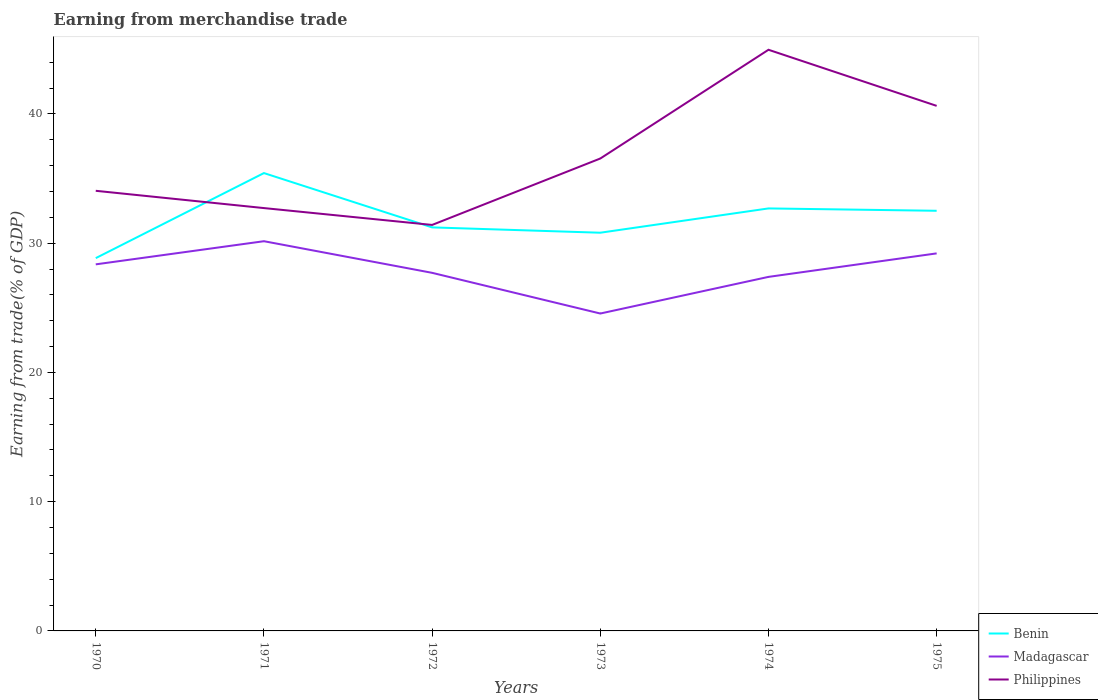Across all years, what is the maximum earnings from trade in Madagascar?
Your answer should be compact. 24.56. In which year was the earnings from trade in Philippines maximum?
Keep it short and to the point. 1972. What is the total earnings from trade in Philippines in the graph?
Keep it short and to the point. 2.64. What is the difference between the highest and the second highest earnings from trade in Madagascar?
Your answer should be compact. 5.59. What is the difference between the highest and the lowest earnings from trade in Benin?
Your answer should be very brief. 3. Is the earnings from trade in Philippines strictly greater than the earnings from trade in Madagascar over the years?
Your answer should be compact. No. What is the difference between two consecutive major ticks on the Y-axis?
Provide a short and direct response. 10. Does the graph contain grids?
Offer a terse response. No. Where does the legend appear in the graph?
Ensure brevity in your answer.  Bottom right. What is the title of the graph?
Keep it short and to the point. Earning from merchandise trade. What is the label or title of the Y-axis?
Make the answer very short. Earning from trade(% of GDP). What is the Earning from trade(% of GDP) of Benin in 1970?
Keep it short and to the point. 28.84. What is the Earning from trade(% of GDP) in Madagascar in 1970?
Your response must be concise. 28.36. What is the Earning from trade(% of GDP) in Philippines in 1970?
Your response must be concise. 34.05. What is the Earning from trade(% of GDP) in Benin in 1971?
Give a very brief answer. 35.42. What is the Earning from trade(% of GDP) of Madagascar in 1971?
Offer a very short reply. 30.15. What is the Earning from trade(% of GDP) in Philippines in 1971?
Keep it short and to the point. 32.71. What is the Earning from trade(% of GDP) of Benin in 1972?
Your answer should be compact. 31.22. What is the Earning from trade(% of GDP) in Madagascar in 1972?
Provide a short and direct response. 27.7. What is the Earning from trade(% of GDP) in Philippines in 1972?
Your answer should be compact. 31.41. What is the Earning from trade(% of GDP) of Benin in 1973?
Offer a very short reply. 30.81. What is the Earning from trade(% of GDP) in Madagascar in 1973?
Give a very brief answer. 24.56. What is the Earning from trade(% of GDP) in Philippines in 1973?
Your answer should be compact. 36.55. What is the Earning from trade(% of GDP) in Benin in 1974?
Make the answer very short. 32.69. What is the Earning from trade(% of GDP) in Madagascar in 1974?
Your answer should be very brief. 27.39. What is the Earning from trade(% of GDP) in Philippines in 1974?
Keep it short and to the point. 44.96. What is the Earning from trade(% of GDP) of Benin in 1975?
Your answer should be very brief. 32.5. What is the Earning from trade(% of GDP) of Madagascar in 1975?
Your answer should be compact. 29.21. What is the Earning from trade(% of GDP) in Philippines in 1975?
Offer a very short reply. 40.62. Across all years, what is the maximum Earning from trade(% of GDP) of Benin?
Give a very brief answer. 35.42. Across all years, what is the maximum Earning from trade(% of GDP) of Madagascar?
Offer a terse response. 30.15. Across all years, what is the maximum Earning from trade(% of GDP) of Philippines?
Ensure brevity in your answer.  44.96. Across all years, what is the minimum Earning from trade(% of GDP) in Benin?
Provide a succinct answer. 28.84. Across all years, what is the minimum Earning from trade(% of GDP) of Madagascar?
Offer a terse response. 24.56. Across all years, what is the minimum Earning from trade(% of GDP) of Philippines?
Your answer should be compact. 31.41. What is the total Earning from trade(% of GDP) of Benin in the graph?
Provide a short and direct response. 191.48. What is the total Earning from trade(% of GDP) in Madagascar in the graph?
Offer a terse response. 167.37. What is the total Earning from trade(% of GDP) in Philippines in the graph?
Provide a succinct answer. 220.31. What is the difference between the Earning from trade(% of GDP) in Benin in 1970 and that in 1971?
Keep it short and to the point. -6.58. What is the difference between the Earning from trade(% of GDP) in Madagascar in 1970 and that in 1971?
Provide a short and direct response. -1.79. What is the difference between the Earning from trade(% of GDP) in Philippines in 1970 and that in 1971?
Your answer should be compact. 1.34. What is the difference between the Earning from trade(% of GDP) in Benin in 1970 and that in 1972?
Offer a very short reply. -2.38. What is the difference between the Earning from trade(% of GDP) of Madagascar in 1970 and that in 1972?
Give a very brief answer. 0.66. What is the difference between the Earning from trade(% of GDP) in Philippines in 1970 and that in 1972?
Your response must be concise. 2.64. What is the difference between the Earning from trade(% of GDP) in Benin in 1970 and that in 1973?
Your answer should be very brief. -1.97. What is the difference between the Earning from trade(% of GDP) in Madagascar in 1970 and that in 1973?
Ensure brevity in your answer.  3.8. What is the difference between the Earning from trade(% of GDP) of Philippines in 1970 and that in 1973?
Provide a short and direct response. -2.5. What is the difference between the Earning from trade(% of GDP) of Benin in 1970 and that in 1974?
Provide a short and direct response. -3.85. What is the difference between the Earning from trade(% of GDP) in Madagascar in 1970 and that in 1974?
Offer a very short reply. 0.97. What is the difference between the Earning from trade(% of GDP) of Philippines in 1970 and that in 1974?
Your response must be concise. -10.91. What is the difference between the Earning from trade(% of GDP) in Benin in 1970 and that in 1975?
Offer a very short reply. -3.66. What is the difference between the Earning from trade(% of GDP) of Madagascar in 1970 and that in 1975?
Provide a succinct answer. -0.85. What is the difference between the Earning from trade(% of GDP) of Philippines in 1970 and that in 1975?
Offer a very short reply. -6.57. What is the difference between the Earning from trade(% of GDP) of Benin in 1971 and that in 1972?
Give a very brief answer. 4.2. What is the difference between the Earning from trade(% of GDP) in Madagascar in 1971 and that in 1972?
Keep it short and to the point. 2.45. What is the difference between the Earning from trade(% of GDP) in Philippines in 1971 and that in 1972?
Give a very brief answer. 1.3. What is the difference between the Earning from trade(% of GDP) of Benin in 1971 and that in 1973?
Provide a succinct answer. 4.61. What is the difference between the Earning from trade(% of GDP) in Madagascar in 1971 and that in 1973?
Make the answer very short. 5.59. What is the difference between the Earning from trade(% of GDP) of Philippines in 1971 and that in 1973?
Keep it short and to the point. -3.83. What is the difference between the Earning from trade(% of GDP) of Benin in 1971 and that in 1974?
Provide a short and direct response. 2.74. What is the difference between the Earning from trade(% of GDP) in Madagascar in 1971 and that in 1974?
Make the answer very short. 2.76. What is the difference between the Earning from trade(% of GDP) of Philippines in 1971 and that in 1974?
Provide a short and direct response. -12.25. What is the difference between the Earning from trade(% of GDP) in Benin in 1971 and that in 1975?
Ensure brevity in your answer.  2.92. What is the difference between the Earning from trade(% of GDP) of Madagascar in 1971 and that in 1975?
Your response must be concise. 0.94. What is the difference between the Earning from trade(% of GDP) of Philippines in 1971 and that in 1975?
Give a very brief answer. -7.91. What is the difference between the Earning from trade(% of GDP) in Benin in 1972 and that in 1973?
Your answer should be very brief. 0.41. What is the difference between the Earning from trade(% of GDP) in Madagascar in 1972 and that in 1973?
Your answer should be very brief. 3.15. What is the difference between the Earning from trade(% of GDP) in Philippines in 1972 and that in 1973?
Keep it short and to the point. -5.14. What is the difference between the Earning from trade(% of GDP) in Benin in 1972 and that in 1974?
Ensure brevity in your answer.  -1.47. What is the difference between the Earning from trade(% of GDP) in Madagascar in 1972 and that in 1974?
Your response must be concise. 0.31. What is the difference between the Earning from trade(% of GDP) of Philippines in 1972 and that in 1974?
Provide a short and direct response. -13.55. What is the difference between the Earning from trade(% of GDP) of Benin in 1972 and that in 1975?
Make the answer very short. -1.28. What is the difference between the Earning from trade(% of GDP) of Madagascar in 1972 and that in 1975?
Your answer should be very brief. -1.51. What is the difference between the Earning from trade(% of GDP) in Philippines in 1972 and that in 1975?
Ensure brevity in your answer.  -9.21. What is the difference between the Earning from trade(% of GDP) of Benin in 1973 and that in 1974?
Give a very brief answer. -1.88. What is the difference between the Earning from trade(% of GDP) of Madagascar in 1973 and that in 1974?
Offer a very short reply. -2.84. What is the difference between the Earning from trade(% of GDP) in Philippines in 1973 and that in 1974?
Offer a terse response. -8.41. What is the difference between the Earning from trade(% of GDP) in Benin in 1973 and that in 1975?
Provide a succinct answer. -1.7. What is the difference between the Earning from trade(% of GDP) of Madagascar in 1973 and that in 1975?
Your answer should be compact. -4.65. What is the difference between the Earning from trade(% of GDP) of Philippines in 1973 and that in 1975?
Offer a very short reply. -4.07. What is the difference between the Earning from trade(% of GDP) of Benin in 1974 and that in 1975?
Your response must be concise. 0.18. What is the difference between the Earning from trade(% of GDP) of Madagascar in 1974 and that in 1975?
Your response must be concise. -1.82. What is the difference between the Earning from trade(% of GDP) of Philippines in 1974 and that in 1975?
Provide a succinct answer. 4.34. What is the difference between the Earning from trade(% of GDP) in Benin in 1970 and the Earning from trade(% of GDP) in Madagascar in 1971?
Provide a short and direct response. -1.31. What is the difference between the Earning from trade(% of GDP) in Benin in 1970 and the Earning from trade(% of GDP) in Philippines in 1971?
Offer a very short reply. -3.87. What is the difference between the Earning from trade(% of GDP) of Madagascar in 1970 and the Earning from trade(% of GDP) of Philippines in 1971?
Give a very brief answer. -4.35. What is the difference between the Earning from trade(% of GDP) in Benin in 1970 and the Earning from trade(% of GDP) in Madagascar in 1972?
Your response must be concise. 1.14. What is the difference between the Earning from trade(% of GDP) in Benin in 1970 and the Earning from trade(% of GDP) in Philippines in 1972?
Your answer should be compact. -2.57. What is the difference between the Earning from trade(% of GDP) in Madagascar in 1970 and the Earning from trade(% of GDP) in Philippines in 1972?
Make the answer very short. -3.05. What is the difference between the Earning from trade(% of GDP) of Benin in 1970 and the Earning from trade(% of GDP) of Madagascar in 1973?
Offer a terse response. 4.29. What is the difference between the Earning from trade(% of GDP) of Benin in 1970 and the Earning from trade(% of GDP) of Philippines in 1973?
Ensure brevity in your answer.  -7.71. What is the difference between the Earning from trade(% of GDP) in Madagascar in 1970 and the Earning from trade(% of GDP) in Philippines in 1973?
Make the answer very short. -8.19. What is the difference between the Earning from trade(% of GDP) in Benin in 1970 and the Earning from trade(% of GDP) in Madagascar in 1974?
Provide a short and direct response. 1.45. What is the difference between the Earning from trade(% of GDP) in Benin in 1970 and the Earning from trade(% of GDP) in Philippines in 1974?
Offer a terse response. -16.12. What is the difference between the Earning from trade(% of GDP) of Madagascar in 1970 and the Earning from trade(% of GDP) of Philippines in 1974?
Keep it short and to the point. -16.6. What is the difference between the Earning from trade(% of GDP) of Benin in 1970 and the Earning from trade(% of GDP) of Madagascar in 1975?
Your response must be concise. -0.37. What is the difference between the Earning from trade(% of GDP) of Benin in 1970 and the Earning from trade(% of GDP) of Philippines in 1975?
Provide a short and direct response. -11.78. What is the difference between the Earning from trade(% of GDP) of Madagascar in 1970 and the Earning from trade(% of GDP) of Philippines in 1975?
Your answer should be very brief. -12.26. What is the difference between the Earning from trade(% of GDP) of Benin in 1971 and the Earning from trade(% of GDP) of Madagascar in 1972?
Provide a short and direct response. 7.72. What is the difference between the Earning from trade(% of GDP) in Benin in 1971 and the Earning from trade(% of GDP) in Philippines in 1972?
Make the answer very short. 4.01. What is the difference between the Earning from trade(% of GDP) in Madagascar in 1971 and the Earning from trade(% of GDP) in Philippines in 1972?
Ensure brevity in your answer.  -1.26. What is the difference between the Earning from trade(% of GDP) in Benin in 1971 and the Earning from trade(% of GDP) in Madagascar in 1973?
Your response must be concise. 10.87. What is the difference between the Earning from trade(% of GDP) of Benin in 1971 and the Earning from trade(% of GDP) of Philippines in 1973?
Your answer should be very brief. -1.13. What is the difference between the Earning from trade(% of GDP) in Madagascar in 1971 and the Earning from trade(% of GDP) in Philippines in 1973?
Provide a short and direct response. -6.4. What is the difference between the Earning from trade(% of GDP) of Benin in 1971 and the Earning from trade(% of GDP) of Madagascar in 1974?
Give a very brief answer. 8.03. What is the difference between the Earning from trade(% of GDP) of Benin in 1971 and the Earning from trade(% of GDP) of Philippines in 1974?
Provide a short and direct response. -9.54. What is the difference between the Earning from trade(% of GDP) of Madagascar in 1971 and the Earning from trade(% of GDP) of Philippines in 1974?
Your answer should be very brief. -14.81. What is the difference between the Earning from trade(% of GDP) in Benin in 1971 and the Earning from trade(% of GDP) in Madagascar in 1975?
Offer a very short reply. 6.21. What is the difference between the Earning from trade(% of GDP) of Benin in 1971 and the Earning from trade(% of GDP) of Philippines in 1975?
Provide a short and direct response. -5.2. What is the difference between the Earning from trade(% of GDP) in Madagascar in 1971 and the Earning from trade(% of GDP) in Philippines in 1975?
Ensure brevity in your answer.  -10.47. What is the difference between the Earning from trade(% of GDP) in Benin in 1972 and the Earning from trade(% of GDP) in Madagascar in 1973?
Keep it short and to the point. 6.66. What is the difference between the Earning from trade(% of GDP) in Benin in 1972 and the Earning from trade(% of GDP) in Philippines in 1973?
Your answer should be very brief. -5.33. What is the difference between the Earning from trade(% of GDP) in Madagascar in 1972 and the Earning from trade(% of GDP) in Philippines in 1973?
Your answer should be compact. -8.84. What is the difference between the Earning from trade(% of GDP) in Benin in 1972 and the Earning from trade(% of GDP) in Madagascar in 1974?
Your answer should be compact. 3.83. What is the difference between the Earning from trade(% of GDP) in Benin in 1972 and the Earning from trade(% of GDP) in Philippines in 1974?
Give a very brief answer. -13.74. What is the difference between the Earning from trade(% of GDP) of Madagascar in 1972 and the Earning from trade(% of GDP) of Philippines in 1974?
Provide a succinct answer. -17.26. What is the difference between the Earning from trade(% of GDP) of Benin in 1972 and the Earning from trade(% of GDP) of Madagascar in 1975?
Give a very brief answer. 2.01. What is the difference between the Earning from trade(% of GDP) in Benin in 1972 and the Earning from trade(% of GDP) in Philippines in 1975?
Provide a succinct answer. -9.4. What is the difference between the Earning from trade(% of GDP) of Madagascar in 1972 and the Earning from trade(% of GDP) of Philippines in 1975?
Your response must be concise. -12.92. What is the difference between the Earning from trade(% of GDP) of Benin in 1973 and the Earning from trade(% of GDP) of Madagascar in 1974?
Keep it short and to the point. 3.42. What is the difference between the Earning from trade(% of GDP) in Benin in 1973 and the Earning from trade(% of GDP) in Philippines in 1974?
Your response must be concise. -14.15. What is the difference between the Earning from trade(% of GDP) in Madagascar in 1973 and the Earning from trade(% of GDP) in Philippines in 1974?
Give a very brief answer. -20.41. What is the difference between the Earning from trade(% of GDP) in Benin in 1973 and the Earning from trade(% of GDP) in Madagascar in 1975?
Your answer should be very brief. 1.6. What is the difference between the Earning from trade(% of GDP) of Benin in 1973 and the Earning from trade(% of GDP) of Philippines in 1975?
Offer a very short reply. -9.81. What is the difference between the Earning from trade(% of GDP) of Madagascar in 1973 and the Earning from trade(% of GDP) of Philippines in 1975?
Offer a very short reply. -16.07. What is the difference between the Earning from trade(% of GDP) of Benin in 1974 and the Earning from trade(% of GDP) of Madagascar in 1975?
Your answer should be compact. 3.48. What is the difference between the Earning from trade(% of GDP) in Benin in 1974 and the Earning from trade(% of GDP) in Philippines in 1975?
Keep it short and to the point. -7.93. What is the difference between the Earning from trade(% of GDP) of Madagascar in 1974 and the Earning from trade(% of GDP) of Philippines in 1975?
Offer a terse response. -13.23. What is the average Earning from trade(% of GDP) of Benin per year?
Make the answer very short. 31.91. What is the average Earning from trade(% of GDP) in Madagascar per year?
Provide a short and direct response. 27.9. What is the average Earning from trade(% of GDP) in Philippines per year?
Give a very brief answer. 36.72. In the year 1970, what is the difference between the Earning from trade(% of GDP) of Benin and Earning from trade(% of GDP) of Madagascar?
Keep it short and to the point. 0.48. In the year 1970, what is the difference between the Earning from trade(% of GDP) in Benin and Earning from trade(% of GDP) in Philippines?
Make the answer very short. -5.21. In the year 1970, what is the difference between the Earning from trade(% of GDP) of Madagascar and Earning from trade(% of GDP) of Philippines?
Your response must be concise. -5.69. In the year 1971, what is the difference between the Earning from trade(% of GDP) of Benin and Earning from trade(% of GDP) of Madagascar?
Your answer should be compact. 5.27. In the year 1971, what is the difference between the Earning from trade(% of GDP) in Benin and Earning from trade(% of GDP) in Philippines?
Offer a very short reply. 2.71. In the year 1971, what is the difference between the Earning from trade(% of GDP) of Madagascar and Earning from trade(% of GDP) of Philippines?
Give a very brief answer. -2.56. In the year 1972, what is the difference between the Earning from trade(% of GDP) in Benin and Earning from trade(% of GDP) in Madagascar?
Offer a very short reply. 3.52. In the year 1972, what is the difference between the Earning from trade(% of GDP) in Benin and Earning from trade(% of GDP) in Philippines?
Offer a very short reply. -0.19. In the year 1972, what is the difference between the Earning from trade(% of GDP) in Madagascar and Earning from trade(% of GDP) in Philippines?
Give a very brief answer. -3.71. In the year 1973, what is the difference between the Earning from trade(% of GDP) in Benin and Earning from trade(% of GDP) in Madagascar?
Ensure brevity in your answer.  6.25. In the year 1973, what is the difference between the Earning from trade(% of GDP) of Benin and Earning from trade(% of GDP) of Philippines?
Ensure brevity in your answer.  -5.74. In the year 1973, what is the difference between the Earning from trade(% of GDP) in Madagascar and Earning from trade(% of GDP) in Philippines?
Give a very brief answer. -11.99. In the year 1974, what is the difference between the Earning from trade(% of GDP) in Benin and Earning from trade(% of GDP) in Madagascar?
Make the answer very short. 5.3. In the year 1974, what is the difference between the Earning from trade(% of GDP) of Benin and Earning from trade(% of GDP) of Philippines?
Your response must be concise. -12.27. In the year 1974, what is the difference between the Earning from trade(% of GDP) in Madagascar and Earning from trade(% of GDP) in Philippines?
Provide a short and direct response. -17.57. In the year 1975, what is the difference between the Earning from trade(% of GDP) of Benin and Earning from trade(% of GDP) of Madagascar?
Offer a very short reply. 3.3. In the year 1975, what is the difference between the Earning from trade(% of GDP) of Benin and Earning from trade(% of GDP) of Philippines?
Keep it short and to the point. -8.12. In the year 1975, what is the difference between the Earning from trade(% of GDP) in Madagascar and Earning from trade(% of GDP) in Philippines?
Your response must be concise. -11.41. What is the ratio of the Earning from trade(% of GDP) of Benin in 1970 to that in 1971?
Offer a terse response. 0.81. What is the ratio of the Earning from trade(% of GDP) in Madagascar in 1970 to that in 1971?
Your response must be concise. 0.94. What is the ratio of the Earning from trade(% of GDP) of Philippines in 1970 to that in 1971?
Keep it short and to the point. 1.04. What is the ratio of the Earning from trade(% of GDP) of Benin in 1970 to that in 1972?
Provide a succinct answer. 0.92. What is the ratio of the Earning from trade(% of GDP) in Madagascar in 1970 to that in 1972?
Your response must be concise. 1.02. What is the ratio of the Earning from trade(% of GDP) in Philippines in 1970 to that in 1972?
Offer a very short reply. 1.08. What is the ratio of the Earning from trade(% of GDP) of Benin in 1970 to that in 1973?
Keep it short and to the point. 0.94. What is the ratio of the Earning from trade(% of GDP) of Madagascar in 1970 to that in 1973?
Your response must be concise. 1.15. What is the ratio of the Earning from trade(% of GDP) in Philippines in 1970 to that in 1973?
Offer a terse response. 0.93. What is the ratio of the Earning from trade(% of GDP) of Benin in 1970 to that in 1974?
Provide a succinct answer. 0.88. What is the ratio of the Earning from trade(% of GDP) in Madagascar in 1970 to that in 1974?
Provide a succinct answer. 1.04. What is the ratio of the Earning from trade(% of GDP) in Philippines in 1970 to that in 1974?
Make the answer very short. 0.76. What is the ratio of the Earning from trade(% of GDP) of Benin in 1970 to that in 1975?
Offer a very short reply. 0.89. What is the ratio of the Earning from trade(% of GDP) in Madagascar in 1970 to that in 1975?
Offer a terse response. 0.97. What is the ratio of the Earning from trade(% of GDP) in Philippines in 1970 to that in 1975?
Ensure brevity in your answer.  0.84. What is the ratio of the Earning from trade(% of GDP) of Benin in 1971 to that in 1972?
Offer a very short reply. 1.13. What is the ratio of the Earning from trade(% of GDP) in Madagascar in 1971 to that in 1972?
Ensure brevity in your answer.  1.09. What is the ratio of the Earning from trade(% of GDP) of Philippines in 1971 to that in 1972?
Make the answer very short. 1.04. What is the ratio of the Earning from trade(% of GDP) of Benin in 1971 to that in 1973?
Your answer should be compact. 1.15. What is the ratio of the Earning from trade(% of GDP) in Madagascar in 1971 to that in 1973?
Offer a terse response. 1.23. What is the ratio of the Earning from trade(% of GDP) of Philippines in 1971 to that in 1973?
Your answer should be very brief. 0.9. What is the ratio of the Earning from trade(% of GDP) of Benin in 1971 to that in 1974?
Provide a succinct answer. 1.08. What is the ratio of the Earning from trade(% of GDP) of Madagascar in 1971 to that in 1974?
Provide a succinct answer. 1.1. What is the ratio of the Earning from trade(% of GDP) in Philippines in 1971 to that in 1974?
Make the answer very short. 0.73. What is the ratio of the Earning from trade(% of GDP) of Benin in 1971 to that in 1975?
Make the answer very short. 1.09. What is the ratio of the Earning from trade(% of GDP) in Madagascar in 1971 to that in 1975?
Your response must be concise. 1.03. What is the ratio of the Earning from trade(% of GDP) in Philippines in 1971 to that in 1975?
Your answer should be very brief. 0.81. What is the ratio of the Earning from trade(% of GDP) of Benin in 1972 to that in 1973?
Make the answer very short. 1.01. What is the ratio of the Earning from trade(% of GDP) in Madagascar in 1972 to that in 1973?
Your answer should be compact. 1.13. What is the ratio of the Earning from trade(% of GDP) of Philippines in 1972 to that in 1973?
Offer a very short reply. 0.86. What is the ratio of the Earning from trade(% of GDP) of Benin in 1972 to that in 1974?
Your answer should be very brief. 0.96. What is the ratio of the Earning from trade(% of GDP) in Madagascar in 1972 to that in 1974?
Provide a short and direct response. 1.01. What is the ratio of the Earning from trade(% of GDP) of Philippines in 1972 to that in 1974?
Offer a very short reply. 0.7. What is the ratio of the Earning from trade(% of GDP) in Benin in 1972 to that in 1975?
Your answer should be compact. 0.96. What is the ratio of the Earning from trade(% of GDP) in Madagascar in 1972 to that in 1975?
Offer a terse response. 0.95. What is the ratio of the Earning from trade(% of GDP) in Philippines in 1972 to that in 1975?
Provide a succinct answer. 0.77. What is the ratio of the Earning from trade(% of GDP) of Benin in 1973 to that in 1974?
Your answer should be very brief. 0.94. What is the ratio of the Earning from trade(% of GDP) of Madagascar in 1973 to that in 1974?
Ensure brevity in your answer.  0.9. What is the ratio of the Earning from trade(% of GDP) in Philippines in 1973 to that in 1974?
Ensure brevity in your answer.  0.81. What is the ratio of the Earning from trade(% of GDP) of Benin in 1973 to that in 1975?
Make the answer very short. 0.95. What is the ratio of the Earning from trade(% of GDP) in Madagascar in 1973 to that in 1975?
Make the answer very short. 0.84. What is the ratio of the Earning from trade(% of GDP) in Philippines in 1973 to that in 1975?
Provide a short and direct response. 0.9. What is the ratio of the Earning from trade(% of GDP) of Benin in 1974 to that in 1975?
Make the answer very short. 1.01. What is the ratio of the Earning from trade(% of GDP) of Madagascar in 1974 to that in 1975?
Provide a succinct answer. 0.94. What is the ratio of the Earning from trade(% of GDP) in Philippines in 1974 to that in 1975?
Your response must be concise. 1.11. What is the difference between the highest and the second highest Earning from trade(% of GDP) in Benin?
Your answer should be compact. 2.74. What is the difference between the highest and the second highest Earning from trade(% of GDP) of Madagascar?
Make the answer very short. 0.94. What is the difference between the highest and the second highest Earning from trade(% of GDP) in Philippines?
Ensure brevity in your answer.  4.34. What is the difference between the highest and the lowest Earning from trade(% of GDP) of Benin?
Offer a very short reply. 6.58. What is the difference between the highest and the lowest Earning from trade(% of GDP) of Madagascar?
Provide a succinct answer. 5.59. What is the difference between the highest and the lowest Earning from trade(% of GDP) of Philippines?
Make the answer very short. 13.55. 